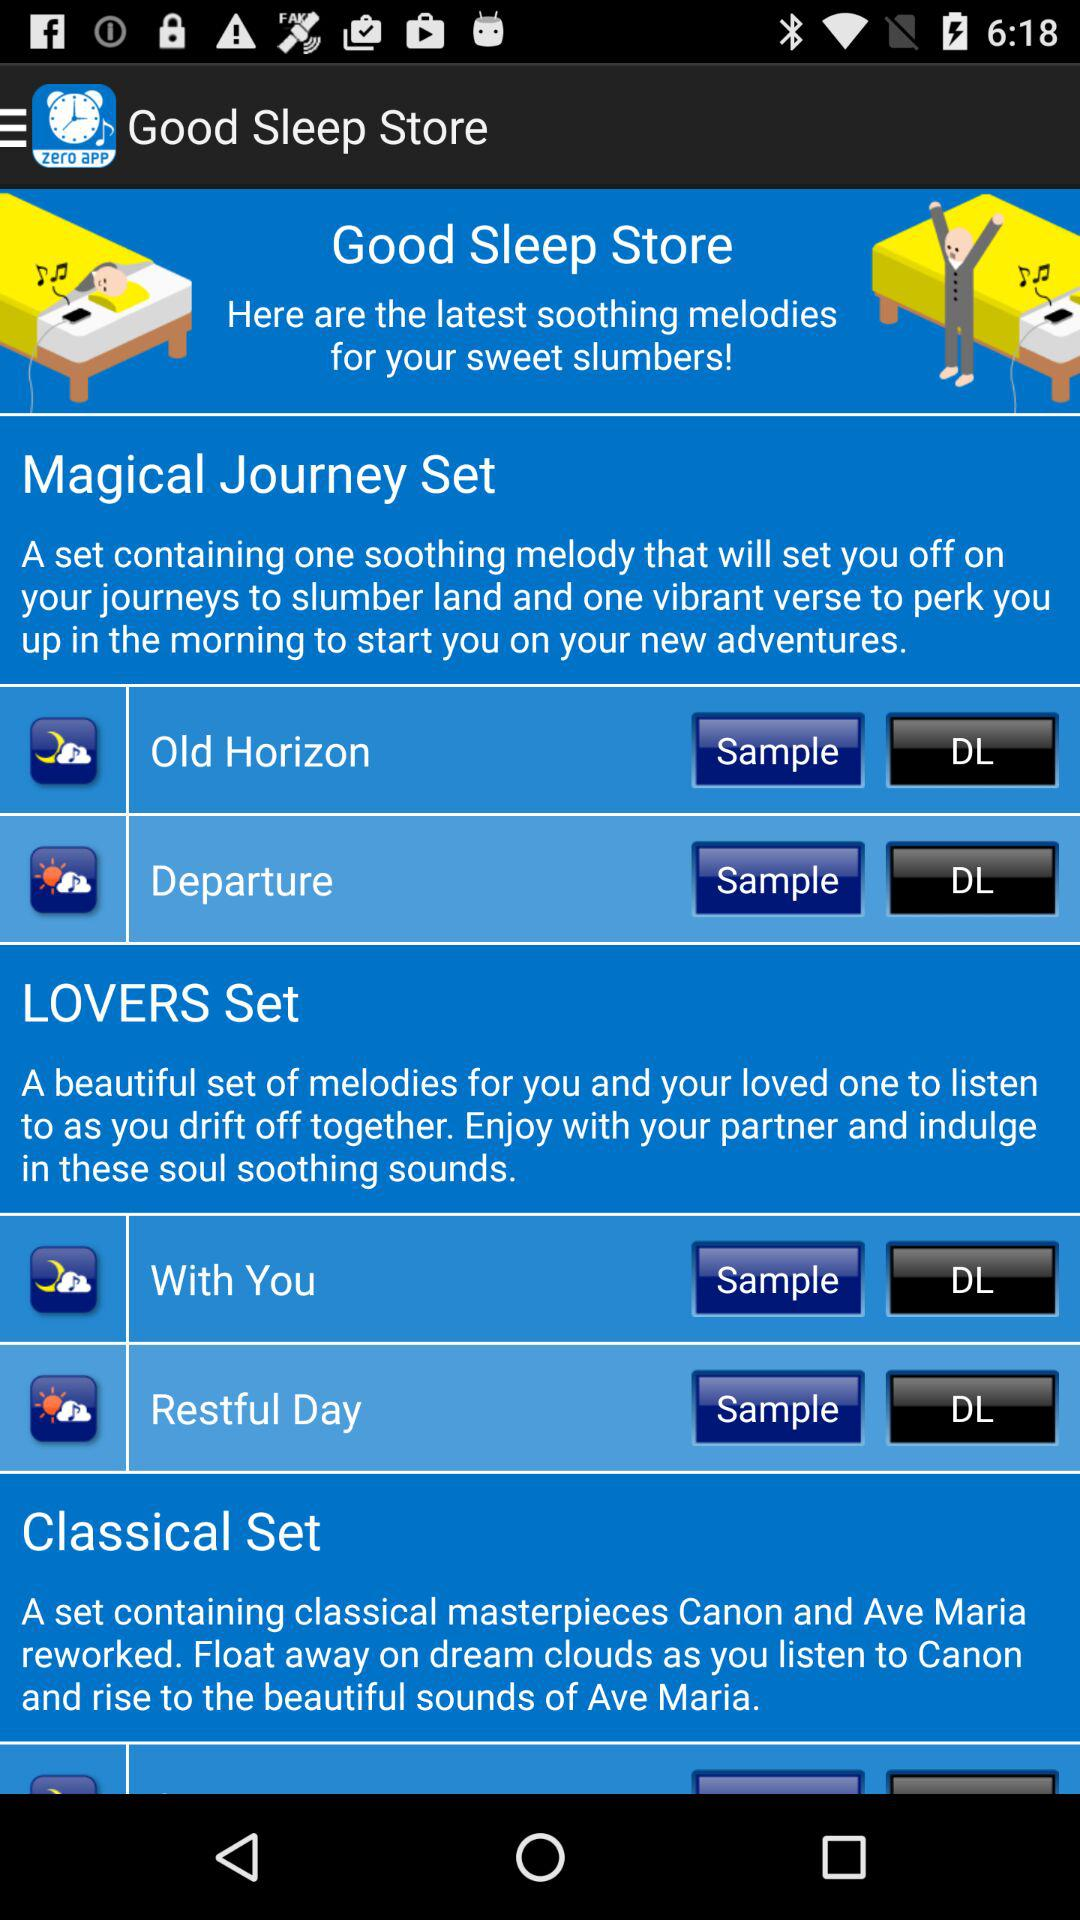How many sets are there?
Answer the question using a single word or phrase. 3 